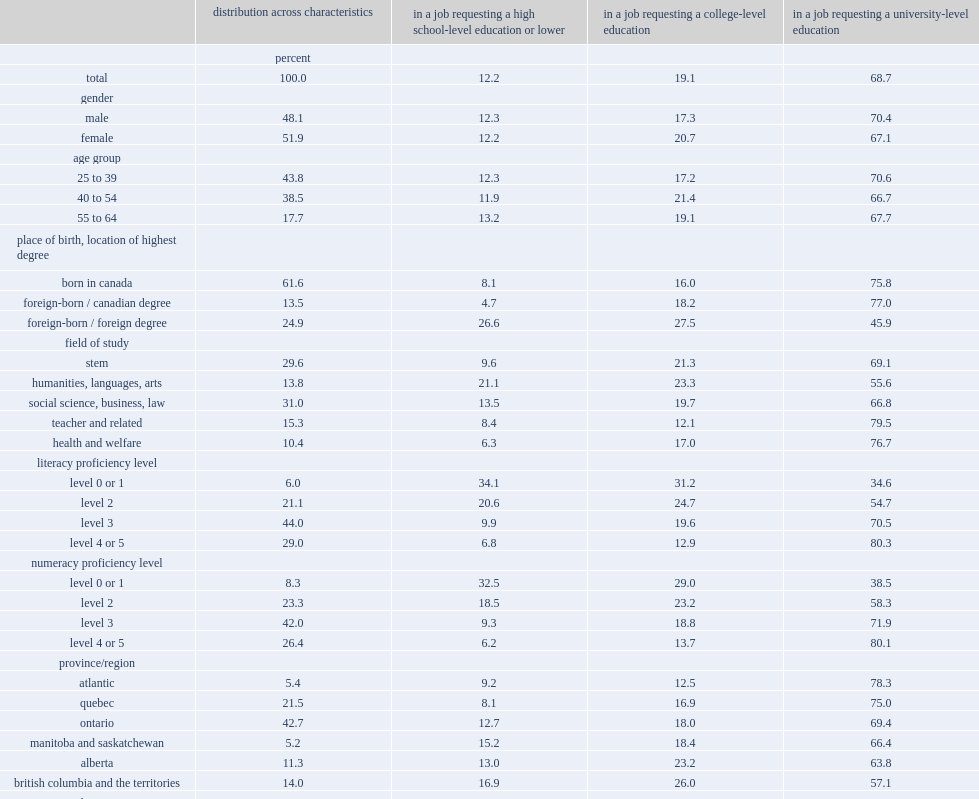Parse the table in full. {'header': ['', 'distribution across characteristics', 'in a job requesting a high school-level education or lower', 'in a job requesting a college-level education', 'in a job requesting a university-level education'], 'rows': [['', 'percent', '', '', ''], ['total', '100.0', '12.2', '19.1', '68.7'], ['gender', '', '', '', ''], ['male', '48.1', '12.3', '17.3', '70.4'], ['female', '51.9', '12.2', '20.7', '67.1'], ['age group', '', '', '', ''], ['25 to 39', '43.8', '12.3', '17.2', '70.6'], ['40 to 54', '38.5', '11.9', '21.4', '66.7'], ['55 to 64', '17.7', '13.2', '19.1', '67.7'], ['place of birth, location of highest degree', '', '', '', ''], ['born in canada', '61.6', '8.1', '16.0', '75.8'], ['foreign-born / canadian degree', '13.5', '4.7', '18.2', '77.0'], ['foreign-born / foreign degree', '24.9', '26.6', '27.5', '45.9'], ['field of study', '', '', '', ''], ['stem', '29.6', '9.6', '21.3', '69.1'], ['humanities, languages, arts', '13.8', '21.1', '23.3', '55.6'], ['social science, business, law', '31.0', '13.5', '19.7', '66.8'], ['teacher and related', '15.3', '8.4', '12.1', '79.5'], ['health and welfare', '10.4', '6.3', '17.0', '76.7'], ['literacy proficiency level', '', '', '', ''], ['level 0 or 1', '6.0', '34.1', '31.2', '34.6'], ['level 2', '21.1', '20.6', '24.7', '54.7'], ['level 3', '44.0', '9.9', '19.6', '70.5'], ['level 4 or 5', '29.0', '6.8', '12.9', '80.3'], ['numeracy proficiency level', '', '', '', ''], ['level 0 or 1', '8.3', '32.5', '29.0', '38.5'], ['level 2', '23.3', '18.5', '23.2', '58.3'], ['level 3', '42.0', '9.3', '18.8', '71.9'], ['level 4 or 5', '26.4', '6.2', '13.7', '80.1'], ['province/region', '', '', '', ''], ['atlantic', '5.4', '9.2', '12.5', '78.3'], ['quebec', '21.5', '8.1', '16.9', '75.0'], ['ontario', '42.7', '12.7', '18.0', '69.4'], ['manitoba and saskatchewan', '5.2', '15.2', '18.4', '66.4'], ['alberta', '11.3', '13.0', '23.2', '63.8'], ['british columbia and the territories', '14.0', '16.9', '26.0', '57.1'], ['mother tongue', '', '', '', ''], ['english', '46.8', '9.1', '17.4', '73.5'], ['french', '17.5', '4.7', '14.3', '81.0'], ['other', '35.6', '20.4', '24.1', '55.5'], ['lives with spouse/partner', '', '', '', ''], ['no', '24.3', '14.9', '19.7', '65.3'], ['yes', '75.7', '11.4', '18.9', '69.7'], ['has a child in the home', '', '', '', ''], ['no', '32.6', '11.5', '19.1', '69.4'], ['yes', '67.4', '12.6', '19.1', '68.2'], ['extent of long-term illness/health problem', '', '', '', ''], ['no health limitation', '73.6', '12.2', '18.7', '69.1'], ['illness exists but is not limiting', '12.8', '9.7', '17.9', '72.3'], ['illness is limiting, including severely', '13.6', '15.2', '23.4', '61.4']]} What's the percentage of working adults aged 25 to 64 with a university education who stated that their job only required a high school education. 12.2. Among working adults aged 25 to 64 with a university education,what were the percentages of those who thought that their job required a college-level education and required a university education respectively? 19.1 68.7. What's the percentage of the "overqualified" population"--those who reported that their job required no more than a high school education. 12.2. Which group's proportion did not vary across age groups or gender? In a job requesting a high school-level education or lower. What's the percentage of foreign-born workers with a foreign university degree who reported that they were in a job requiring a high school education. 26.6. What's the percentage of university graduates whose mother tongue was neither english nor french and said they were working in a job that required no more than a high school diploma. 20.4. Among people who had a degree in humanities, languages or arts,what's the percentage of those who said that they were working in a high school-level position. 21.1. Among people who had a degree in social science, business or law ,what's the percentage of those who said that they were working in a high school-level position. 13.5. Among university graduates whose literacy skills were in the lowest range (levels 0 and 1) and in level 2 ,what were the percentages of those who reported that their current job required no more than a high school education respectively? 34.1 20.6. Among university graduates whose literacy skills in level 3 and in level 4 or level 5,what were the percentages of those who reported that their job required no more than a high school diploma respectively? 9.9 6.8. 